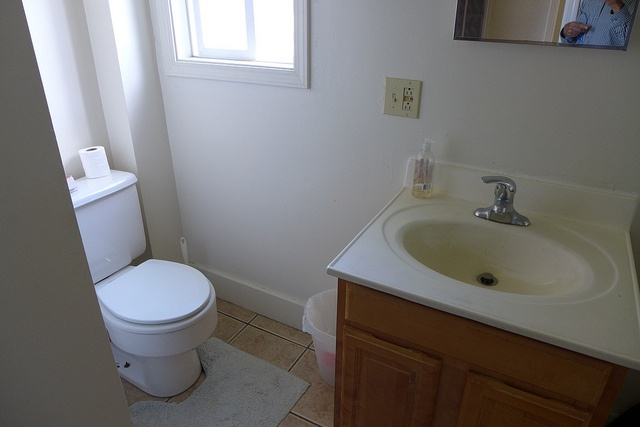Describe the objects in this image and their specific colors. I can see sink in gray, darkgreen, and black tones, toilet in gray, darkgray, and lavender tones, people in gray, black, and darkblue tones, and bottle in gray tones in this image. 